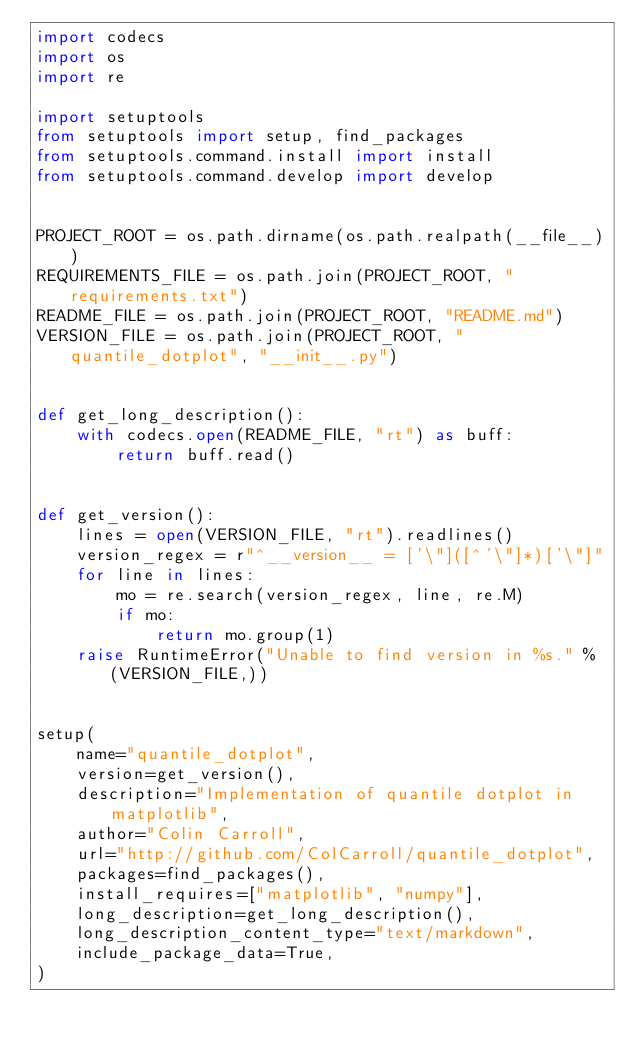<code> <loc_0><loc_0><loc_500><loc_500><_Python_>import codecs
import os
import re

import setuptools
from setuptools import setup, find_packages
from setuptools.command.install import install
from setuptools.command.develop import develop


PROJECT_ROOT = os.path.dirname(os.path.realpath(__file__))
REQUIREMENTS_FILE = os.path.join(PROJECT_ROOT, "requirements.txt")
README_FILE = os.path.join(PROJECT_ROOT, "README.md")
VERSION_FILE = os.path.join(PROJECT_ROOT, "quantile_dotplot", "__init__.py")


def get_long_description():
    with codecs.open(README_FILE, "rt") as buff:
        return buff.read()


def get_version():
    lines = open(VERSION_FILE, "rt").readlines()
    version_regex = r"^__version__ = ['\"]([^'\"]*)['\"]"
    for line in lines:
        mo = re.search(version_regex, line, re.M)
        if mo:
            return mo.group(1)
    raise RuntimeError("Unable to find version in %s." % (VERSION_FILE,))


setup(
    name="quantile_dotplot",
    version=get_version(),
    description="Implementation of quantile dotplot in matplotlib",
    author="Colin Carroll",
    url="http://github.com/ColCarroll/quantile_dotplot",
    packages=find_packages(),
    install_requires=["matplotlib", "numpy"],
    long_description=get_long_description(),
    long_description_content_type="text/markdown",
    include_package_data=True,
)
</code> 